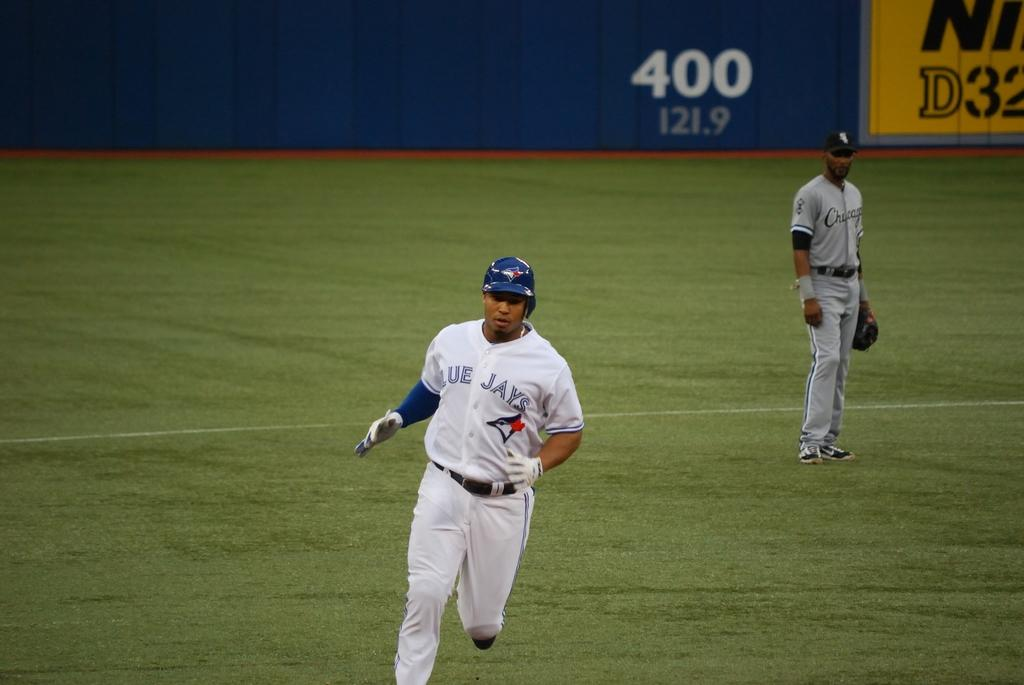<image>
Share a concise interpretation of the image provided. A baseball game is underway and the player running for the base is wearing a Blue Jays uniform. 